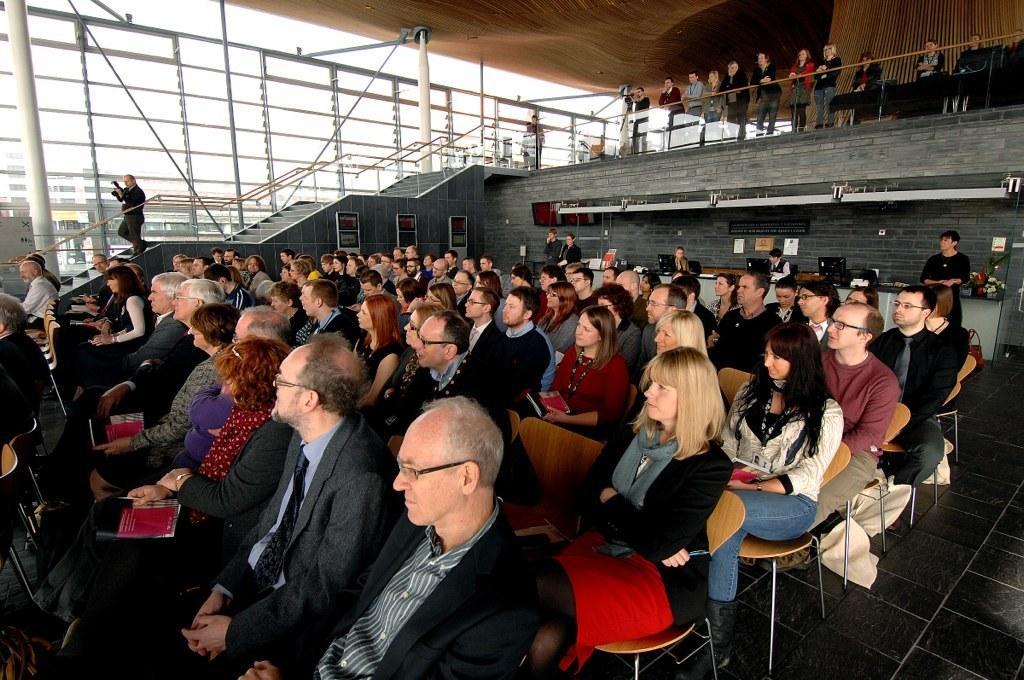In one or two sentences, can you explain what this image depicts? there are many people sitting on the chair and at the left there are stairs. on the top there are people standing and watching the people at the bottom. 